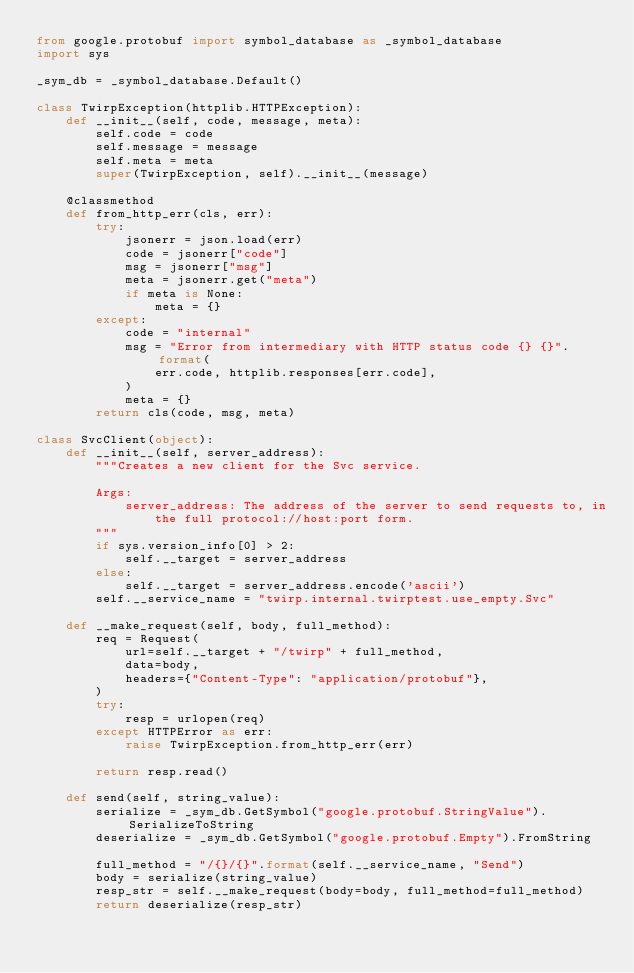Convert code to text. <code><loc_0><loc_0><loc_500><loc_500><_Python_>from google.protobuf import symbol_database as _symbol_database
import sys

_sym_db = _symbol_database.Default()

class TwirpException(httplib.HTTPException):
    def __init__(self, code, message, meta):
        self.code = code
        self.message = message
        self.meta = meta
        super(TwirpException, self).__init__(message)

    @classmethod
    def from_http_err(cls, err):
        try:
            jsonerr = json.load(err)
            code = jsonerr["code"]
            msg = jsonerr["msg"]
            meta = jsonerr.get("meta")
            if meta is None:
                meta = {}
        except:
            code = "internal"
            msg = "Error from intermediary with HTTP status code {} {}".format(
                err.code, httplib.responses[err.code],
            )
            meta = {}
        return cls(code, msg, meta)

class SvcClient(object):
    def __init__(self, server_address):
        """Creates a new client for the Svc service.

        Args:
            server_address: The address of the server to send requests to, in
                the full protocol://host:port form.
        """
        if sys.version_info[0] > 2:
            self.__target = server_address
        else:
            self.__target = server_address.encode('ascii')
        self.__service_name = "twirp.internal.twirptest.use_empty.Svc"

    def __make_request(self, body, full_method):
        req = Request(
            url=self.__target + "/twirp" + full_method,
            data=body,
            headers={"Content-Type": "application/protobuf"},
        )
        try:
            resp = urlopen(req)
        except HTTPError as err:
            raise TwirpException.from_http_err(err)

        return resp.read()

    def send(self, string_value):
        serialize = _sym_db.GetSymbol("google.protobuf.StringValue").SerializeToString
        deserialize = _sym_db.GetSymbol("google.protobuf.Empty").FromString

        full_method = "/{}/{}".format(self.__service_name, "Send")
        body = serialize(string_value)
        resp_str = self.__make_request(body=body, full_method=full_method)
        return deserialize(resp_str)

</code> 